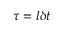<formula> <loc_0><loc_0><loc_500><loc_500>\tau = l \delta t</formula> 